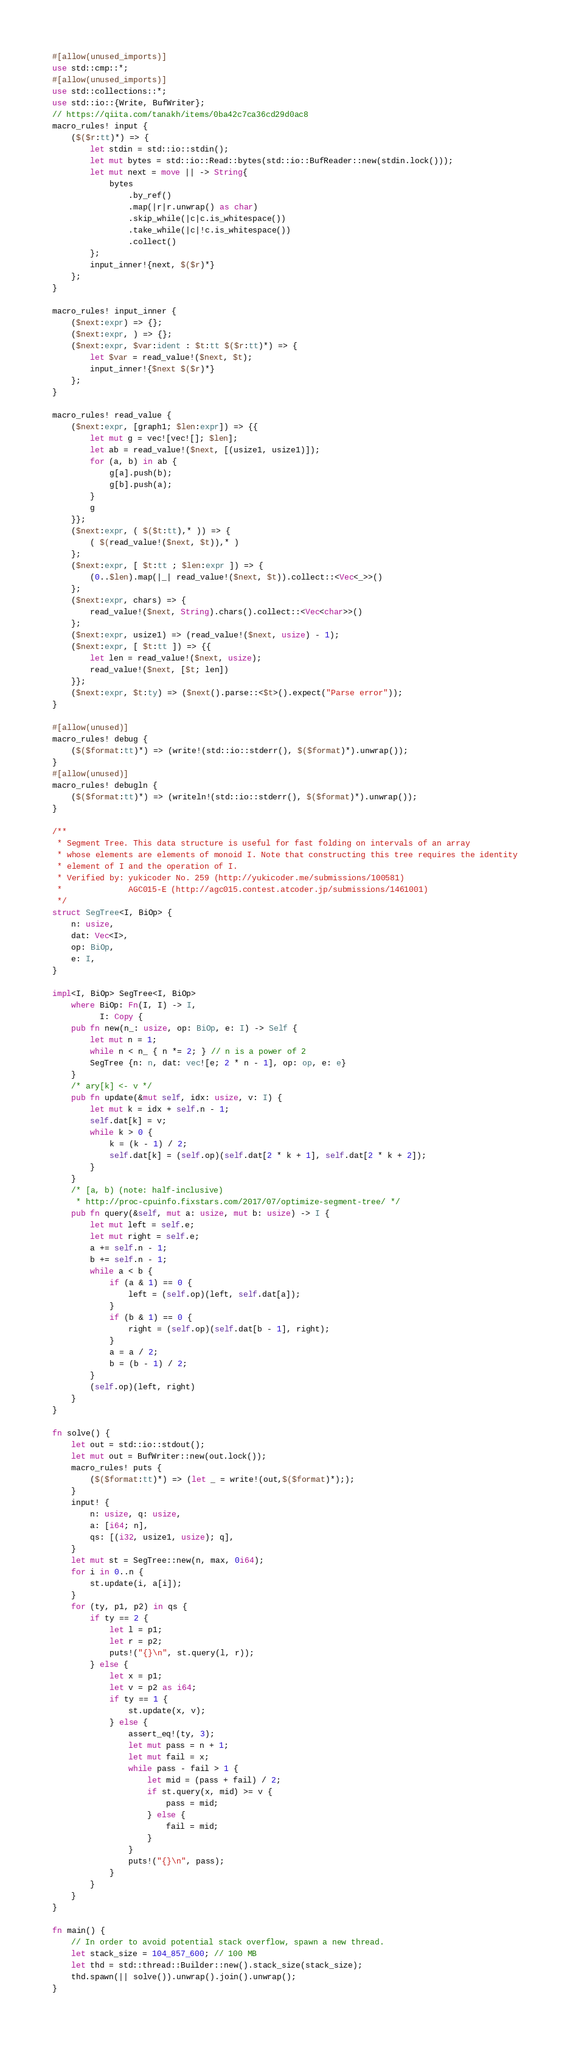Convert code to text. <code><loc_0><loc_0><loc_500><loc_500><_Rust_>#[allow(unused_imports)]
use std::cmp::*;
#[allow(unused_imports)]
use std::collections::*;
use std::io::{Write, BufWriter};
// https://qiita.com/tanakh/items/0ba42c7ca36cd29d0ac8
macro_rules! input {
    ($($r:tt)*) => {
        let stdin = std::io::stdin();
        let mut bytes = std::io::Read::bytes(std::io::BufReader::new(stdin.lock()));
        let mut next = move || -> String{
            bytes
                .by_ref()
                .map(|r|r.unwrap() as char)
                .skip_while(|c|c.is_whitespace())
                .take_while(|c|!c.is_whitespace())
                .collect()
        };
        input_inner!{next, $($r)*}
    };
}

macro_rules! input_inner {
    ($next:expr) => {};
    ($next:expr, ) => {};
    ($next:expr, $var:ident : $t:tt $($r:tt)*) => {
        let $var = read_value!($next, $t);
        input_inner!{$next $($r)*}
    };
}

macro_rules! read_value {
    ($next:expr, [graph1; $len:expr]) => {{
        let mut g = vec![vec![]; $len];
        let ab = read_value!($next, [(usize1, usize1)]);
        for (a, b) in ab {
            g[a].push(b);
            g[b].push(a);
        }
        g
    }};
    ($next:expr, ( $($t:tt),* )) => {
        ( $(read_value!($next, $t)),* )
    };
    ($next:expr, [ $t:tt ; $len:expr ]) => {
        (0..$len).map(|_| read_value!($next, $t)).collect::<Vec<_>>()
    };
    ($next:expr, chars) => {
        read_value!($next, String).chars().collect::<Vec<char>>()
    };
    ($next:expr, usize1) => (read_value!($next, usize) - 1);
    ($next:expr, [ $t:tt ]) => {{
        let len = read_value!($next, usize);
        read_value!($next, [$t; len])
    }};
    ($next:expr, $t:ty) => ($next().parse::<$t>().expect("Parse error"));
}

#[allow(unused)]
macro_rules! debug {
    ($($format:tt)*) => (write!(std::io::stderr(), $($format)*).unwrap());
}
#[allow(unused)]
macro_rules! debugln {
    ($($format:tt)*) => (writeln!(std::io::stderr(), $($format)*).unwrap());
}

/**
 * Segment Tree. This data structure is useful for fast folding on intervals of an array
 * whose elements are elements of monoid I. Note that constructing this tree requires the identity
 * element of I and the operation of I.
 * Verified by: yukicoder No. 259 (http://yukicoder.me/submissions/100581)
 *              AGC015-E (http://agc015.contest.atcoder.jp/submissions/1461001)
 */
struct SegTree<I, BiOp> {
    n: usize,
    dat: Vec<I>,
    op: BiOp,
    e: I,
}

impl<I, BiOp> SegTree<I, BiOp>
    where BiOp: Fn(I, I) -> I,
          I: Copy {
    pub fn new(n_: usize, op: BiOp, e: I) -> Self {
        let mut n = 1;
        while n < n_ { n *= 2; } // n is a power of 2
        SegTree {n: n, dat: vec![e; 2 * n - 1], op: op, e: e}
    }
    /* ary[k] <- v */
    pub fn update(&mut self, idx: usize, v: I) {
        let mut k = idx + self.n - 1;
        self.dat[k] = v;
        while k > 0 {
            k = (k - 1) / 2;
            self.dat[k] = (self.op)(self.dat[2 * k + 1], self.dat[2 * k + 2]);
        }
    }
    /* [a, b) (note: half-inclusive)
     * http://proc-cpuinfo.fixstars.com/2017/07/optimize-segment-tree/ */
    pub fn query(&self, mut a: usize, mut b: usize) -> I {
        let mut left = self.e;
        let mut right = self.e;
        a += self.n - 1;
        b += self.n - 1;
        while a < b {
            if (a & 1) == 0 {
                left = (self.op)(left, self.dat[a]);
            }
            if (b & 1) == 0 {
                right = (self.op)(self.dat[b - 1], right);
            }
            a = a / 2;
            b = (b - 1) / 2;
        }
        (self.op)(left, right)
    }
}

fn solve() {
    let out = std::io::stdout();
    let mut out = BufWriter::new(out.lock());
    macro_rules! puts {
        ($($format:tt)*) => (let _ = write!(out,$($format)*););
    }
    input! {
        n: usize, q: usize,
        a: [i64; n],
        qs: [(i32, usize1, usize); q],
    }
    let mut st = SegTree::new(n, max, 0i64);
    for i in 0..n {
        st.update(i, a[i]);
    }
    for (ty, p1, p2) in qs {
        if ty == 2 {
            let l = p1;
            let r = p2;
            puts!("{}\n", st.query(l, r));
        } else {
            let x = p1;
            let v = p2 as i64;
            if ty == 1 {
                st.update(x, v);
            } else {
                assert_eq!(ty, 3);
                let mut pass = n + 1;
                let mut fail = x;
                while pass - fail > 1 {
                    let mid = (pass + fail) / 2;
                    if st.query(x, mid) >= v {
                        pass = mid;
                    } else {
                        fail = mid;
                    }
                }
                puts!("{}\n", pass);
            }
        }
    }
}

fn main() {
    // In order to avoid potential stack overflow, spawn a new thread.
    let stack_size = 104_857_600; // 100 MB
    let thd = std::thread::Builder::new().stack_size(stack_size);
    thd.spawn(|| solve()).unwrap().join().unwrap();
}
</code> 